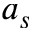<formula> <loc_0><loc_0><loc_500><loc_500>a _ { s }</formula> 